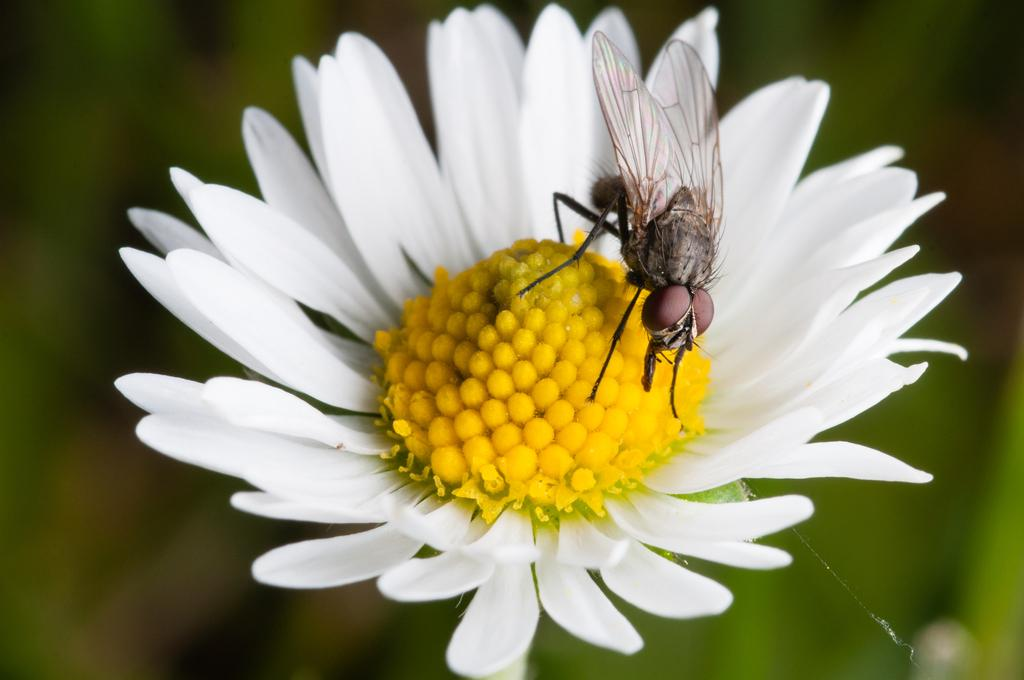What is the main subject of the picture? The main subject of the picture is a flower. Can you describe the color of the flower? The flower is white and yellow in color. Are there any other elements present in the picture besides the flower? Yes, there is a fly on the flower. What is the reason for the credit card being used in the image? There is no credit card present in the image; it features a flower with a fly on it. Can you describe the position of the person's knee in the image? There is no person or knee visible in the image; it only shows a flower and a fly. 